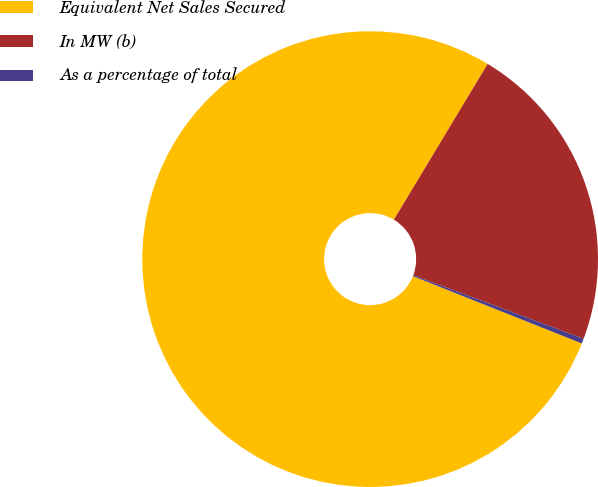<chart> <loc_0><loc_0><loc_500><loc_500><pie_chart><fcel>Equivalent Net Sales Secured<fcel>In MW (b)<fcel>As a percentage of total<nl><fcel>77.59%<fcel>22.06%<fcel>0.35%<nl></chart> 